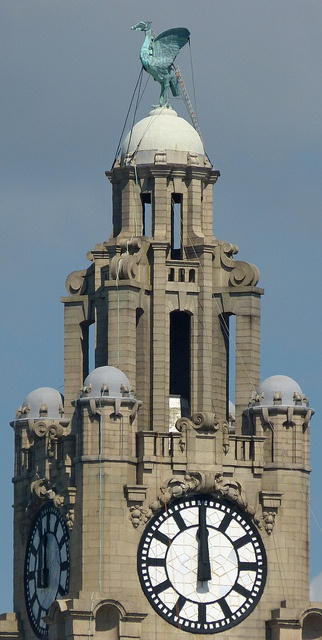Describe the objects in this image and their specific colors. I can see clock in gray, white, and black tones and clock in gray, black, blue, and darkblue tones in this image. 